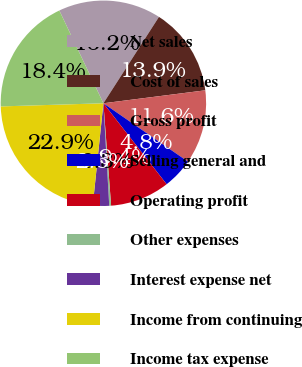Convert chart to OTSL. <chart><loc_0><loc_0><loc_500><loc_500><pie_chart><fcel>Net sales<fcel>Cost of sales<fcel>Gross profit<fcel>Selling general and<fcel>Operating profit<fcel>Other expenses<fcel>Interest expense net<fcel>Income from continuing<fcel>Income tax expense<nl><fcel>16.16%<fcel>13.89%<fcel>11.63%<fcel>4.83%<fcel>9.36%<fcel>0.29%<fcel>2.56%<fcel>22.86%<fcel>18.43%<nl></chart> 